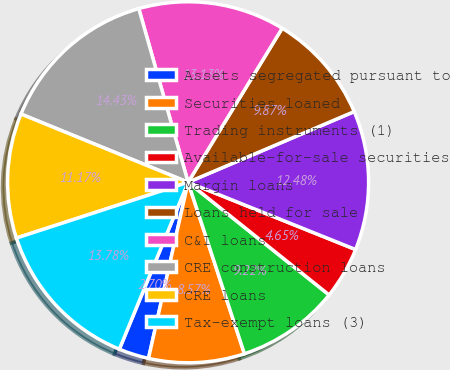<chart> <loc_0><loc_0><loc_500><loc_500><pie_chart><fcel>Assets segregated pursuant to<fcel>Securities loaned<fcel>Trading instruments (1)<fcel>Available-for-sale securities<fcel>Margin loans<fcel>Loans held for sale<fcel>C&I loans<fcel>CRE construction loans<fcel>CRE loans<fcel>Tax-exempt loans (3)<nl><fcel>2.7%<fcel>8.57%<fcel>9.22%<fcel>4.65%<fcel>12.48%<fcel>9.87%<fcel>13.13%<fcel>14.43%<fcel>11.17%<fcel>13.78%<nl></chart> 